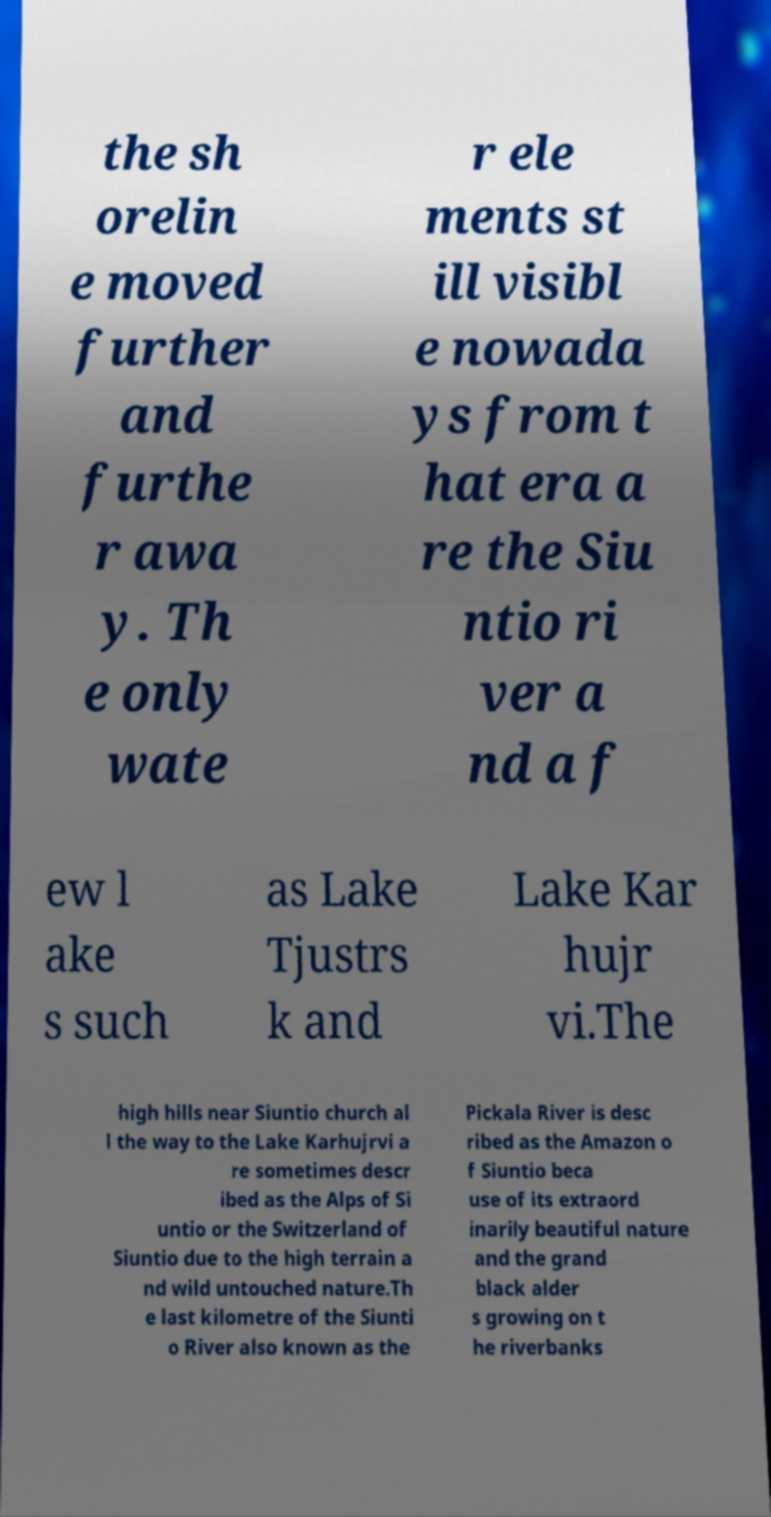Could you assist in decoding the text presented in this image and type it out clearly? the sh orelin e moved further and furthe r awa y. Th e only wate r ele ments st ill visibl e nowada ys from t hat era a re the Siu ntio ri ver a nd a f ew l ake s such as Lake Tjustrs k and Lake Kar hujr vi.The high hills near Siuntio church al l the way to the Lake Karhujrvi a re sometimes descr ibed as the Alps of Si untio or the Switzerland of Siuntio due to the high terrain a nd wild untouched nature.Th e last kilometre of the Siunti o River also known as the Pickala River is desc ribed as the Amazon o f Siuntio beca use of its extraord inarily beautiful nature and the grand black alder s growing on t he riverbanks 